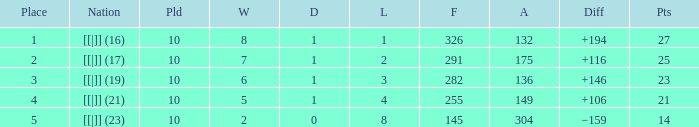 How many table points are listed for the deficit is +194?  1.0. Would you be able to parse every entry in this table? {'header': ['Place', 'Nation', 'Pld', 'W', 'D', 'L', 'F', 'A', 'Diff', 'Pts'], 'rows': [['1', '[[|]] (16)', '10', '8', '1', '1', '326', '132', '+194', '27'], ['2', '[[|]] (17)', '10', '7', '1', '2', '291', '175', '+116', '25'], ['3', '[[|]] (19)', '10', '6', '1', '3', '282', '136', '+146', '23'], ['4', '[[|]] (21)', '10', '5', '1', '4', '255', '149', '+106', '21'], ['5', '[[|]] (23)', '10', '2', '0', '8', '145', '304', '−159', '14']]} 